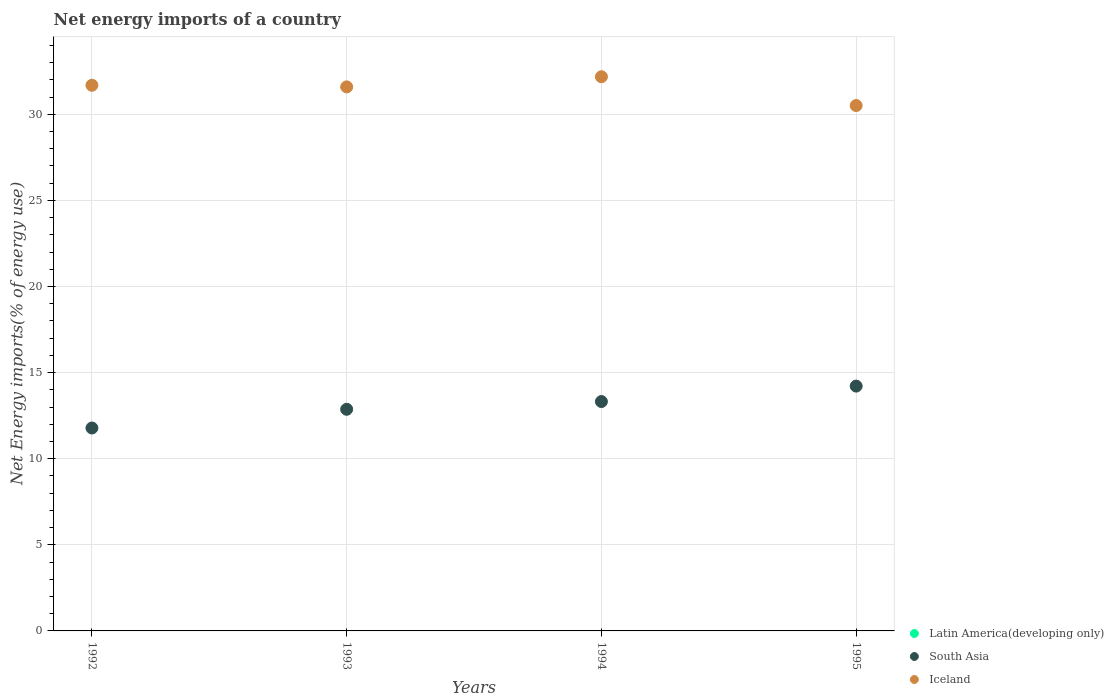How many different coloured dotlines are there?
Provide a short and direct response. 2. What is the net energy imports in Latin America(developing only) in 1994?
Keep it short and to the point. 0. Across all years, what is the maximum net energy imports in South Asia?
Your answer should be compact. 14.22. Across all years, what is the minimum net energy imports in South Asia?
Provide a short and direct response. 11.78. What is the total net energy imports in Iceland in the graph?
Offer a very short reply. 125.98. What is the difference between the net energy imports in South Asia in 1992 and that in 1994?
Keep it short and to the point. -1.54. What is the difference between the net energy imports in South Asia in 1994 and the net energy imports in Latin America(developing only) in 1992?
Your answer should be compact. 13.32. What is the average net energy imports in Iceland per year?
Keep it short and to the point. 31.49. In the year 1994, what is the difference between the net energy imports in South Asia and net energy imports in Iceland?
Keep it short and to the point. -18.86. What is the ratio of the net energy imports in South Asia in 1992 to that in 1994?
Provide a short and direct response. 0.88. Is the difference between the net energy imports in South Asia in 1994 and 1995 greater than the difference between the net energy imports in Iceland in 1994 and 1995?
Offer a very short reply. No. What is the difference between the highest and the second highest net energy imports in South Asia?
Make the answer very short. 0.9. What is the difference between the highest and the lowest net energy imports in South Asia?
Make the answer very short. 2.43. In how many years, is the net energy imports in Latin America(developing only) greater than the average net energy imports in Latin America(developing only) taken over all years?
Your response must be concise. 0. Is the net energy imports in Iceland strictly greater than the net energy imports in South Asia over the years?
Ensure brevity in your answer.  Yes. Is the net energy imports in Latin America(developing only) strictly less than the net energy imports in Iceland over the years?
Your answer should be very brief. Yes. How many years are there in the graph?
Give a very brief answer. 4. Are the values on the major ticks of Y-axis written in scientific E-notation?
Ensure brevity in your answer.  No. Does the graph contain any zero values?
Your answer should be very brief. Yes. How many legend labels are there?
Keep it short and to the point. 3. What is the title of the graph?
Provide a short and direct response. Net energy imports of a country. Does "Burundi" appear as one of the legend labels in the graph?
Keep it short and to the point. No. What is the label or title of the Y-axis?
Offer a very short reply. Net Energy imports(% of energy use). What is the Net Energy imports(% of energy use) in South Asia in 1992?
Keep it short and to the point. 11.78. What is the Net Energy imports(% of energy use) of Iceland in 1992?
Provide a short and direct response. 31.69. What is the Net Energy imports(% of energy use) of Latin America(developing only) in 1993?
Ensure brevity in your answer.  0. What is the Net Energy imports(% of energy use) of South Asia in 1993?
Offer a very short reply. 12.87. What is the Net Energy imports(% of energy use) of Iceland in 1993?
Your response must be concise. 31.59. What is the Net Energy imports(% of energy use) in South Asia in 1994?
Keep it short and to the point. 13.32. What is the Net Energy imports(% of energy use) in Iceland in 1994?
Ensure brevity in your answer.  32.18. What is the Net Energy imports(% of energy use) of Latin America(developing only) in 1995?
Your answer should be very brief. 0. What is the Net Energy imports(% of energy use) in South Asia in 1995?
Ensure brevity in your answer.  14.22. What is the Net Energy imports(% of energy use) of Iceland in 1995?
Make the answer very short. 30.51. Across all years, what is the maximum Net Energy imports(% of energy use) in South Asia?
Provide a short and direct response. 14.22. Across all years, what is the maximum Net Energy imports(% of energy use) in Iceland?
Provide a succinct answer. 32.18. Across all years, what is the minimum Net Energy imports(% of energy use) of South Asia?
Provide a succinct answer. 11.78. Across all years, what is the minimum Net Energy imports(% of energy use) of Iceland?
Give a very brief answer. 30.51. What is the total Net Energy imports(% of energy use) of Latin America(developing only) in the graph?
Offer a very short reply. 0. What is the total Net Energy imports(% of energy use) of South Asia in the graph?
Provide a short and direct response. 52.19. What is the total Net Energy imports(% of energy use) in Iceland in the graph?
Provide a short and direct response. 125.98. What is the difference between the Net Energy imports(% of energy use) of South Asia in 1992 and that in 1993?
Provide a short and direct response. -1.09. What is the difference between the Net Energy imports(% of energy use) of Iceland in 1992 and that in 1993?
Make the answer very short. 0.09. What is the difference between the Net Energy imports(% of energy use) of South Asia in 1992 and that in 1994?
Give a very brief answer. -1.54. What is the difference between the Net Energy imports(% of energy use) in Iceland in 1992 and that in 1994?
Your answer should be very brief. -0.49. What is the difference between the Net Energy imports(% of energy use) in South Asia in 1992 and that in 1995?
Your answer should be very brief. -2.43. What is the difference between the Net Energy imports(% of energy use) in Iceland in 1992 and that in 1995?
Offer a terse response. 1.18. What is the difference between the Net Energy imports(% of energy use) of South Asia in 1993 and that in 1994?
Ensure brevity in your answer.  -0.45. What is the difference between the Net Energy imports(% of energy use) in Iceland in 1993 and that in 1994?
Your answer should be compact. -0.59. What is the difference between the Net Energy imports(% of energy use) of South Asia in 1993 and that in 1995?
Ensure brevity in your answer.  -1.35. What is the difference between the Net Energy imports(% of energy use) of Iceland in 1993 and that in 1995?
Provide a succinct answer. 1.08. What is the difference between the Net Energy imports(% of energy use) in South Asia in 1994 and that in 1995?
Your answer should be compact. -0.9. What is the difference between the Net Energy imports(% of energy use) of Iceland in 1994 and that in 1995?
Make the answer very short. 1.67. What is the difference between the Net Energy imports(% of energy use) of South Asia in 1992 and the Net Energy imports(% of energy use) of Iceland in 1993?
Ensure brevity in your answer.  -19.81. What is the difference between the Net Energy imports(% of energy use) in South Asia in 1992 and the Net Energy imports(% of energy use) in Iceland in 1994?
Your answer should be compact. -20.4. What is the difference between the Net Energy imports(% of energy use) of South Asia in 1992 and the Net Energy imports(% of energy use) of Iceland in 1995?
Offer a terse response. -18.73. What is the difference between the Net Energy imports(% of energy use) in South Asia in 1993 and the Net Energy imports(% of energy use) in Iceland in 1994?
Keep it short and to the point. -19.31. What is the difference between the Net Energy imports(% of energy use) in South Asia in 1993 and the Net Energy imports(% of energy use) in Iceland in 1995?
Give a very brief answer. -17.64. What is the difference between the Net Energy imports(% of energy use) in South Asia in 1994 and the Net Energy imports(% of energy use) in Iceland in 1995?
Keep it short and to the point. -17.19. What is the average Net Energy imports(% of energy use) of South Asia per year?
Offer a very short reply. 13.05. What is the average Net Energy imports(% of energy use) in Iceland per year?
Your answer should be very brief. 31.49. In the year 1992, what is the difference between the Net Energy imports(% of energy use) of South Asia and Net Energy imports(% of energy use) of Iceland?
Offer a terse response. -19.9. In the year 1993, what is the difference between the Net Energy imports(% of energy use) of South Asia and Net Energy imports(% of energy use) of Iceland?
Your answer should be very brief. -18.72. In the year 1994, what is the difference between the Net Energy imports(% of energy use) in South Asia and Net Energy imports(% of energy use) in Iceland?
Your response must be concise. -18.86. In the year 1995, what is the difference between the Net Energy imports(% of energy use) of South Asia and Net Energy imports(% of energy use) of Iceland?
Provide a succinct answer. -16.29. What is the ratio of the Net Energy imports(% of energy use) of South Asia in 1992 to that in 1993?
Keep it short and to the point. 0.92. What is the ratio of the Net Energy imports(% of energy use) in Iceland in 1992 to that in 1993?
Give a very brief answer. 1. What is the ratio of the Net Energy imports(% of energy use) in South Asia in 1992 to that in 1994?
Your answer should be compact. 0.88. What is the ratio of the Net Energy imports(% of energy use) of Iceland in 1992 to that in 1994?
Your answer should be very brief. 0.98. What is the ratio of the Net Energy imports(% of energy use) of South Asia in 1992 to that in 1995?
Your answer should be very brief. 0.83. What is the ratio of the Net Energy imports(% of energy use) of Iceland in 1992 to that in 1995?
Offer a terse response. 1.04. What is the ratio of the Net Energy imports(% of energy use) in South Asia in 1993 to that in 1994?
Keep it short and to the point. 0.97. What is the ratio of the Net Energy imports(% of energy use) of Iceland in 1993 to that in 1994?
Your answer should be very brief. 0.98. What is the ratio of the Net Energy imports(% of energy use) in South Asia in 1993 to that in 1995?
Ensure brevity in your answer.  0.91. What is the ratio of the Net Energy imports(% of energy use) of Iceland in 1993 to that in 1995?
Your answer should be very brief. 1.04. What is the ratio of the Net Energy imports(% of energy use) of South Asia in 1994 to that in 1995?
Offer a very short reply. 0.94. What is the ratio of the Net Energy imports(% of energy use) of Iceland in 1994 to that in 1995?
Give a very brief answer. 1.05. What is the difference between the highest and the second highest Net Energy imports(% of energy use) in South Asia?
Your response must be concise. 0.9. What is the difference between the highest and the second highest Net Energy imports(% of energy use) in Iceland?
Your answer should be very brief. 0.49. What is the difference between the highest and the lowest Net Energy imports(% of energy use) of South Asia?
Make the answer very short. 2.43. What is the difference between the highest and the lowest Net Energy imports(% of energy use) of Iceland?
Provide a short and direct response. 1.67. 